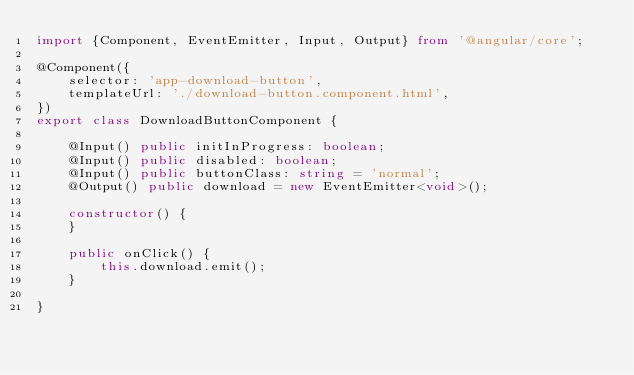<code> <loc_0><loc_0><loc_500><loc_500><_TypeScript_>import {Component, EventEmitter, Input, Output} from '@angular/core';

@Component({
    selector: 'app-download-button',
    templateUrl: './download-button.component.html',
})
export class DownloadButtonComponent {

    @Input() public initInProgress: boolean;
    @Input() public disabled: boolean;
    @Input() public buttonClass: string = 'normal';
    @Output() public download = new EventEmitter<void>();

    constructor() {
    }

    public onClick() {
        this.download.emit();
    }

}
</code> 